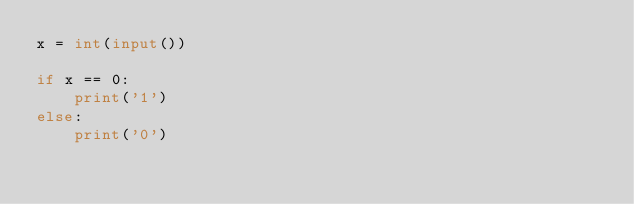Convert code to text. <code><loc_0><loc_0><loc_500><loc_500><_Python_>x = int(input())

if x == 0:
    print('1')
else:
    print('0')</code> 